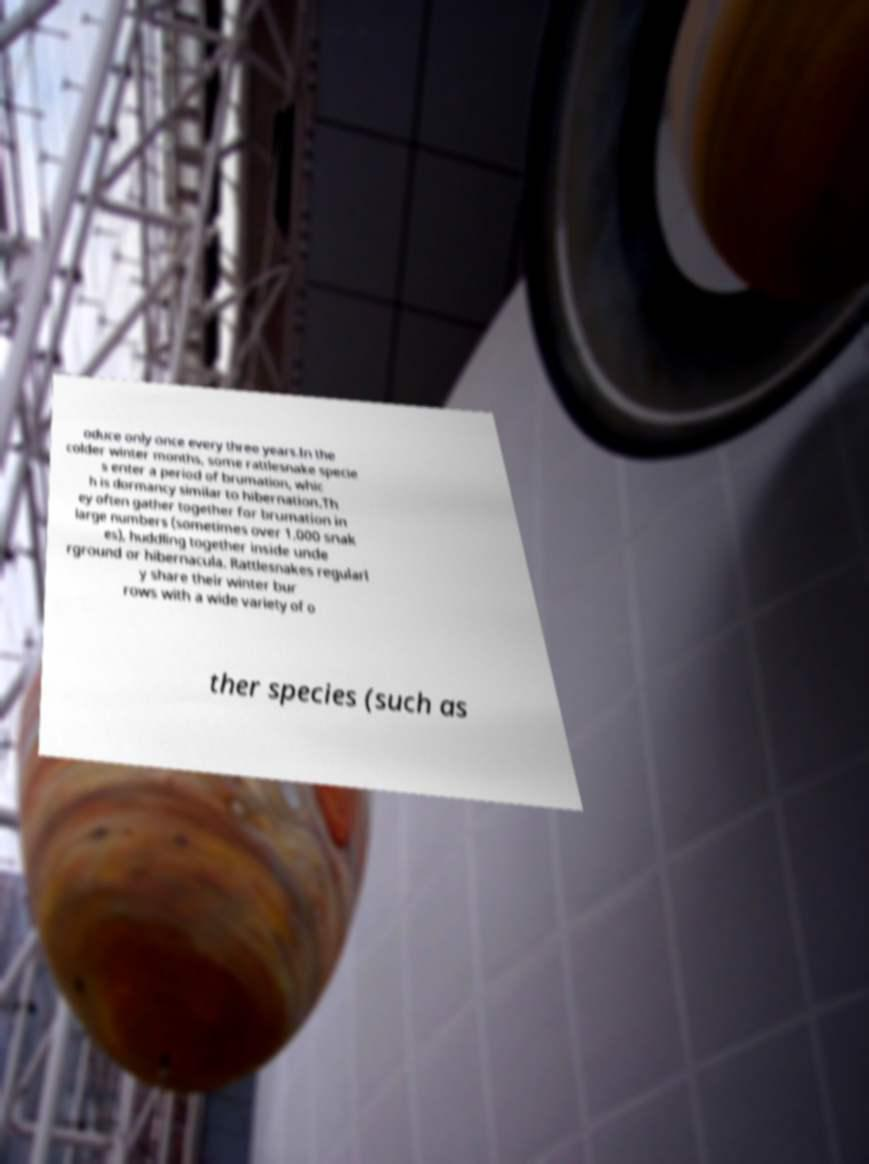Can you read and provide the text displayed in the image?This photo seems to have some interesting text. Can you extract and type it out for me? oduce only once every three years.In the colder winter months, some rattlesnake specie s enter a period of brumation, whic h is dormancy similar to hibernation.Th ey often gather together for brumation in large numbers (sometimes over 1,000 snak es), huddling together inside unde rground or hibernacula. Rattlesnakes regularl y share their winter bur rows with a wide variety of o ther species (such as 